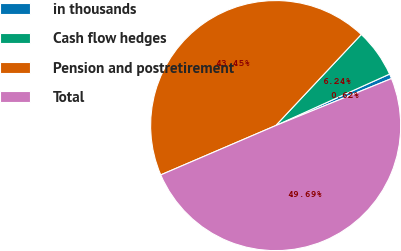Convert chart. <chart><loc_0><loc_0><loc_500><loc_500><pie_chart><fcel>in thousands<fcel>Cash flow hedges<fcel>Pension and postretirement<fcel>Total<nl><fcel>0.62%<fcel>6.24%<fcel>43.45%<fcel>49.69%<nl></chart> 